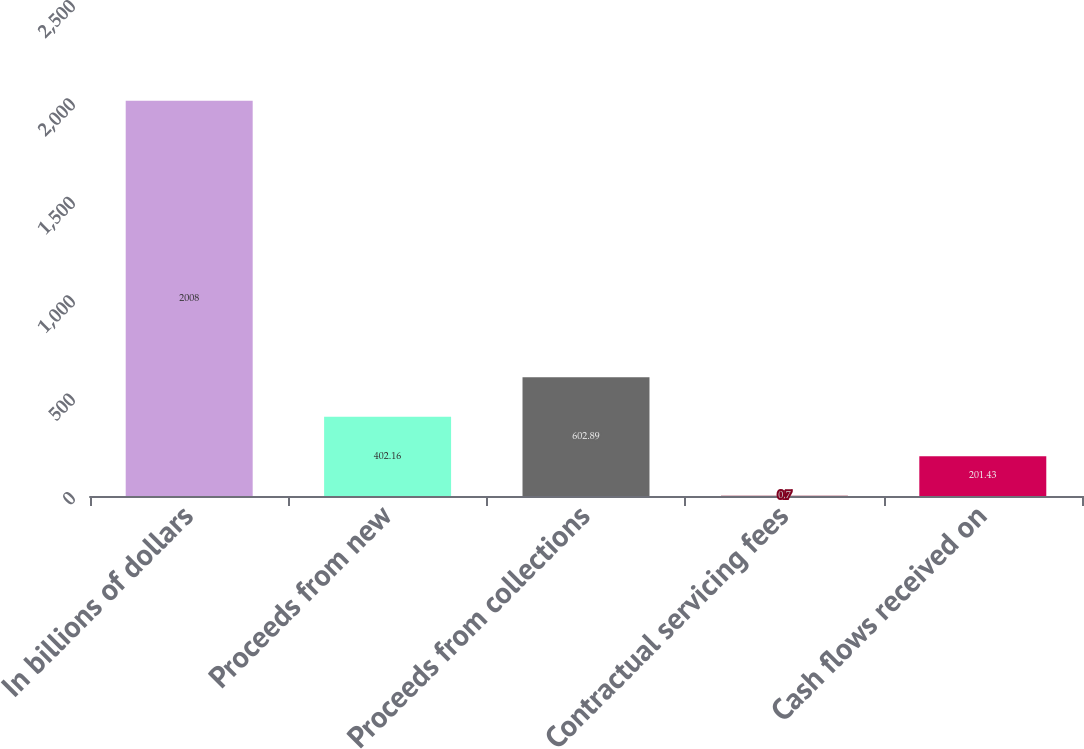<chart> <loc_0><loc_0><loc_500><loc_500><bar_chart><fcel>In billions of dollars<fcel>Proceeds from new<fcel>Proceeds from collections<fcel>Contractual servicing fees<fcel>Cash flows received on<nl><fcel>2008<fcel>402.16<fcel>602.89<fcel>0.7<fcel>201.43<nl></chart> 